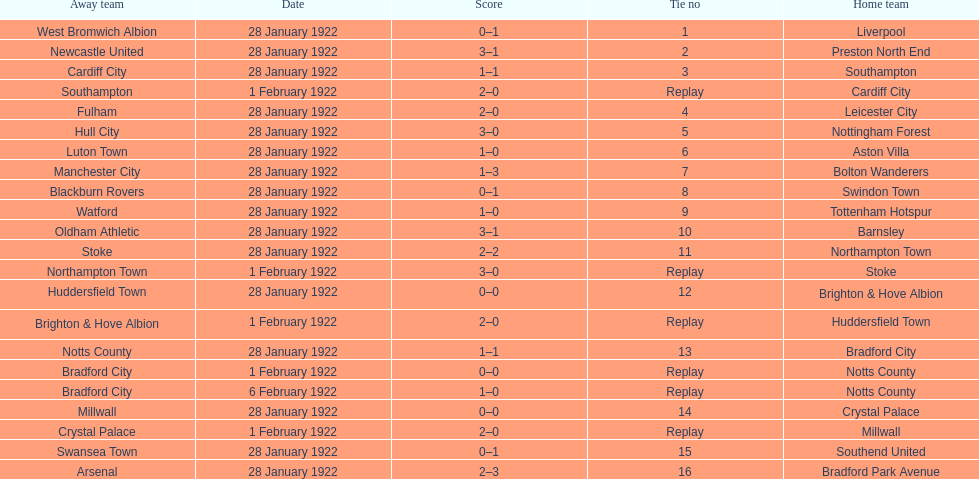How many games had no points scored? 3. 